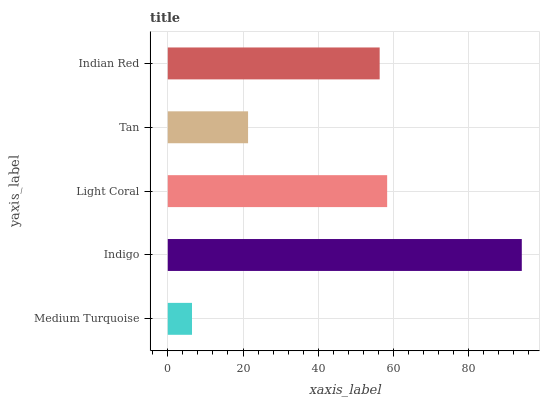Is Medium Turquoise the minimum?
Answer yes or no. Yes. Is Indigo the maximum?
Answer yes or no. Yes. Is Light Coral the minimum?
Answer yes or no. No. Is Light Coral the maximum?
Answer yes or no. No. Is Indigo greater than Light Coral?
Answer yes or no. Yes. Is Light Coral less than Indigo?
Answer yes or no. Yes. Is Light Coral greater than Indigo?
Answer yes or no. No. Is Indigo less than Light Coral?
Answer yes or no. No. Is Indian Red the high median?
Answer yes or no. Yes. Is Indian Red the low median?
Answer yes or no. Yes. Is Light Coral the high median?
Answer yes or no. No. Is Medium Turquoise the low median?
Answer yes or no. No. 